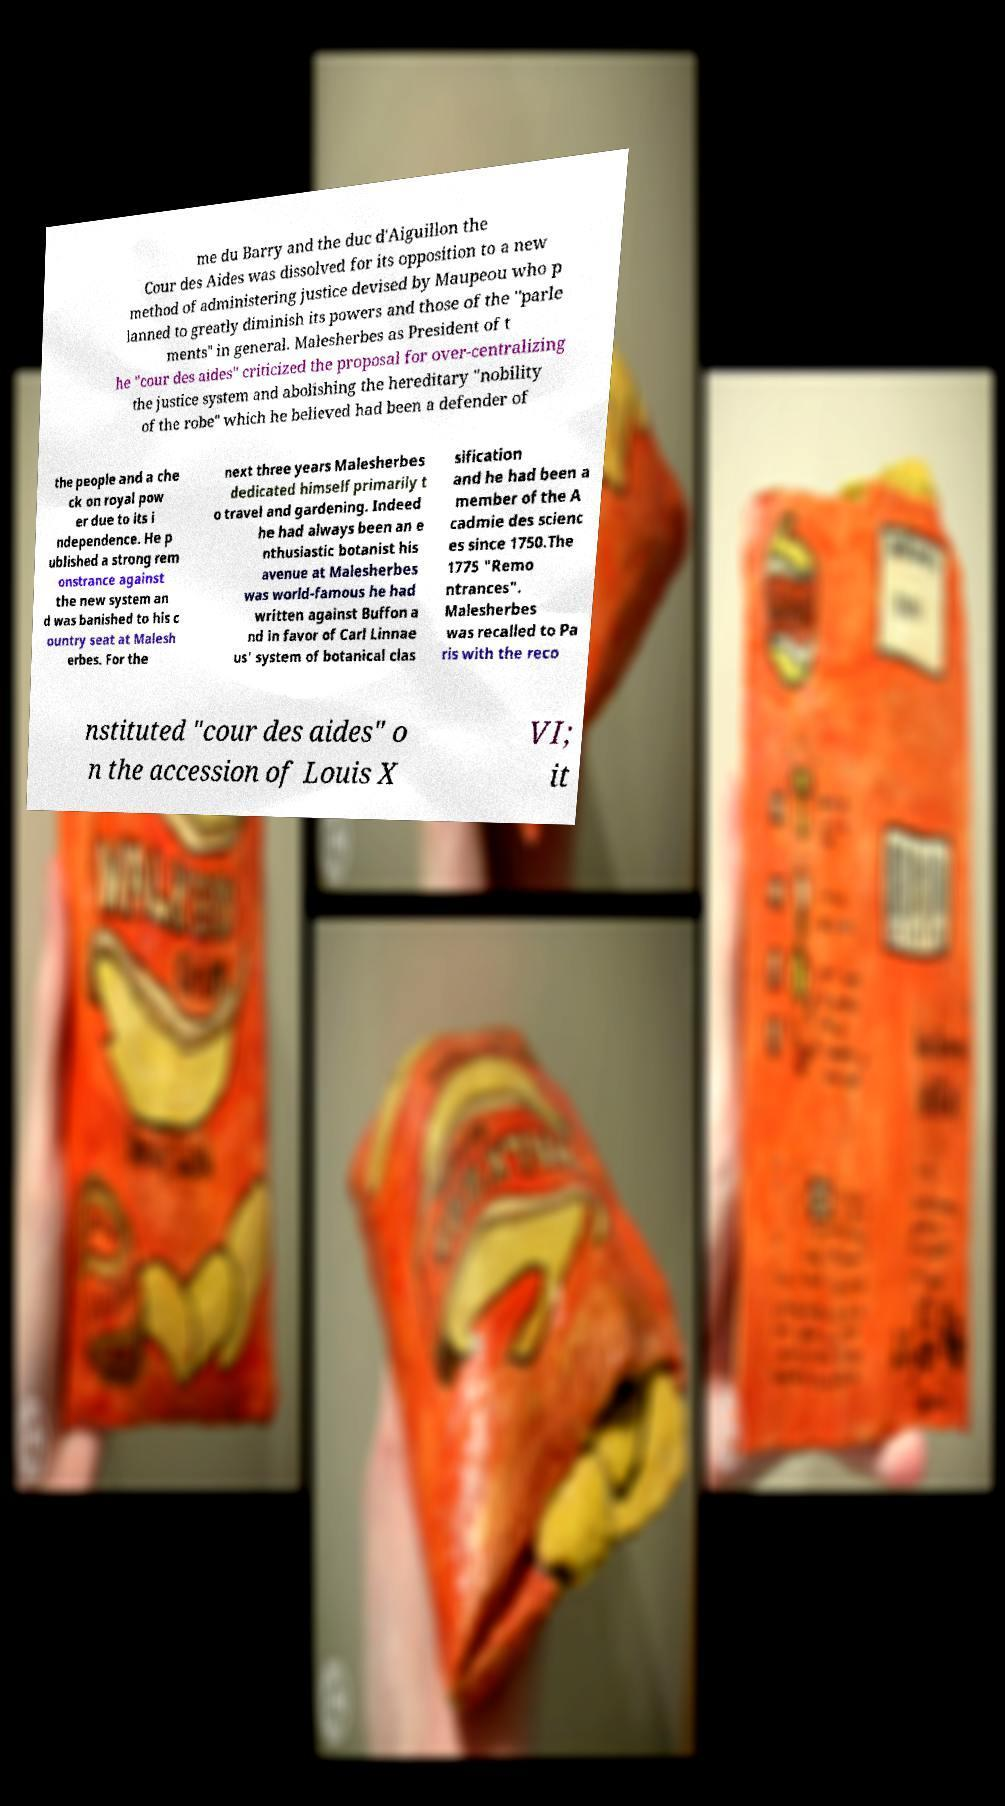Can you read and provide the text displayed in the image?This photo seems to have some interesting text. Can you extract and type it out for me? me du Barry and the duc d'Aiguillon the Cour des Aides was dissolved for its opposition to a new method of administering justice devised by Maupeou who p lanned to greatly diminish its powers and those of the "parle ments" in general. Malesherbes as President of t he "cour des aides" criticized the proposal for over-centralizing the justice system and abolishing the hereditary "nobility of the robe" which he believed had been a defender of the people and a che ck on royal pow er due to its i ndependence. He p ublished a strong rem onstrance against the new system an d was banished to his c ountry seat at Malesh erbes. For the next three years Malesherbes dedicated himself primarily t o travel and gardening. Indeed he had always been an e nthusiastic botanist his avenue at Malesherbes was world-famous he had written against Buffon a nd in favor of Carl Linnae us' system of botanical clas sification and he had been a member of the A cadmie des scienc es since 1750.The 1775 "Remo ntrances". Malesherbes was recalled to Pa ris with the reco nstituted "cour des aides" o n the accession of Louis X VI; it 